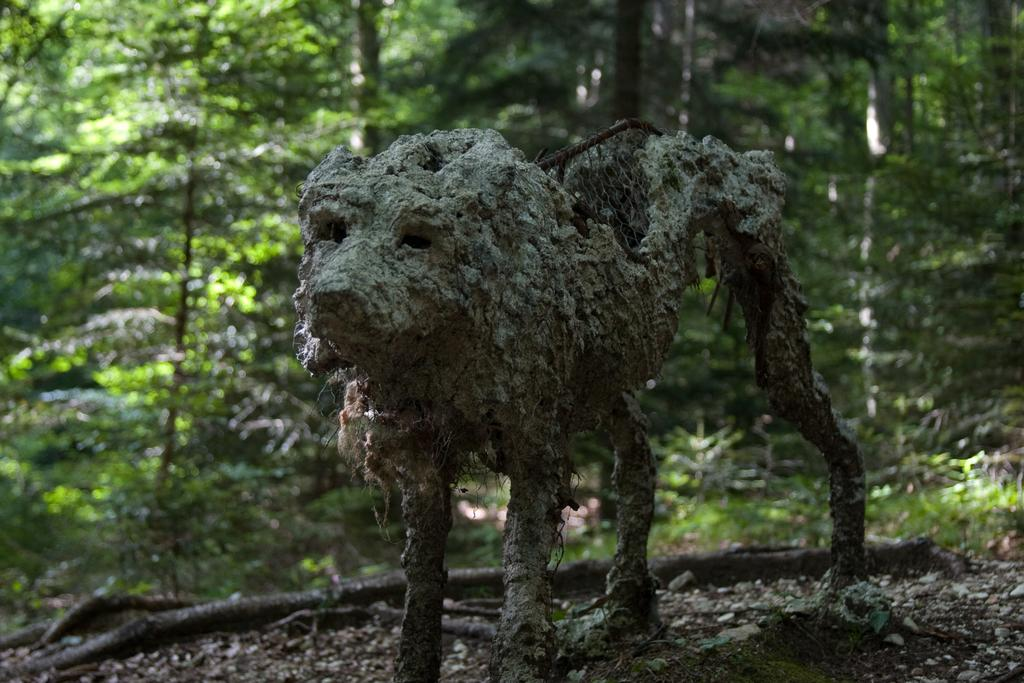What type of animal shape can be seen on the land in the image? There is a shape of an animal on the land in the image. What can be seen in the background of the image? There are trees and plants on the ground in the background of the image. How many cherries are hanging from the branches of the trees in the image? There is no mention of cherries in the image; the background only includes trees and plants. 